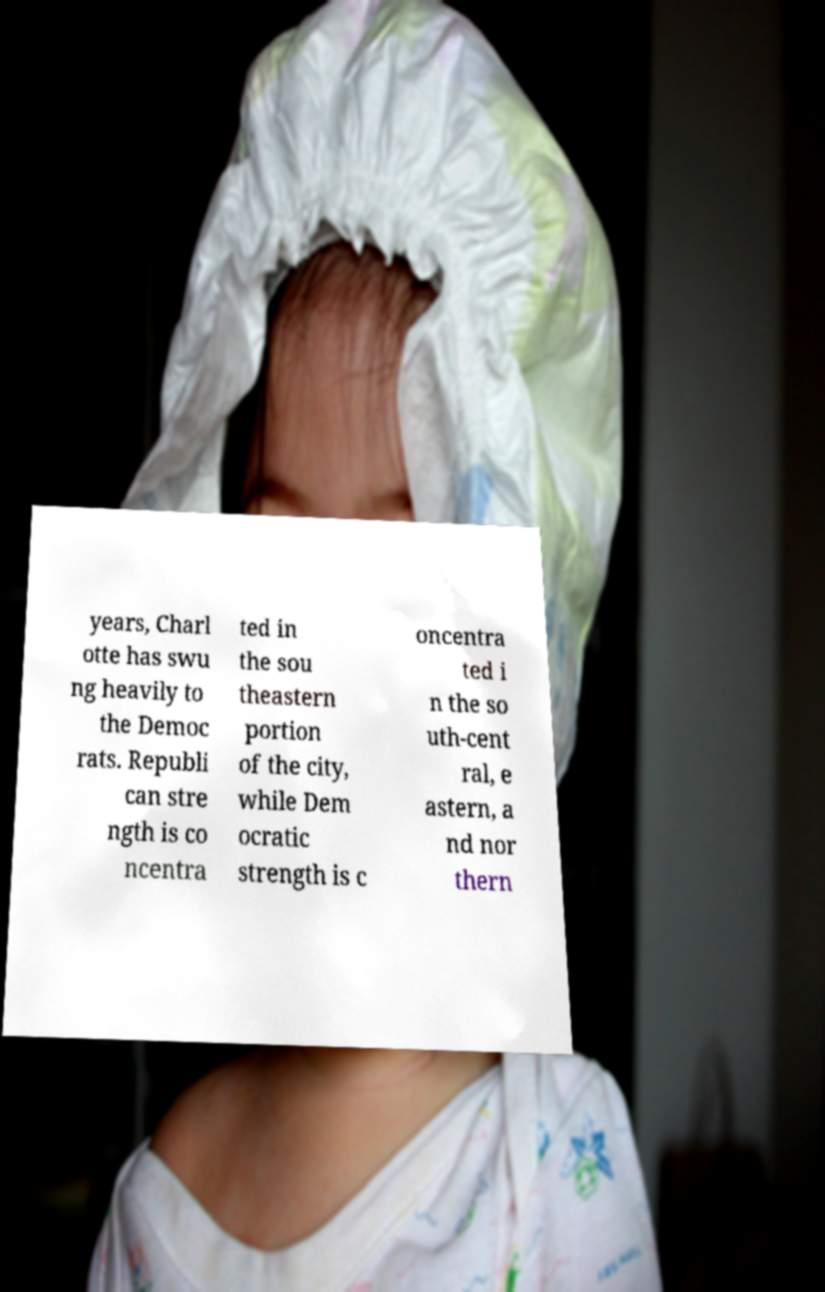Please identify and transcribe the text found in this image. years, Charl otte has swu ng heavily to the Democ rats. Republi can stre ngth is co ncentra ted in the sou theastern portion of the city, while Dem ocratic strength is c oncentra ted i n the so uth-cent ral, e astern, a nd nor thern 